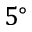<formula> <loc_0><loc_0><loc_500><loc_500>5 ^ { \circ }</formula> 